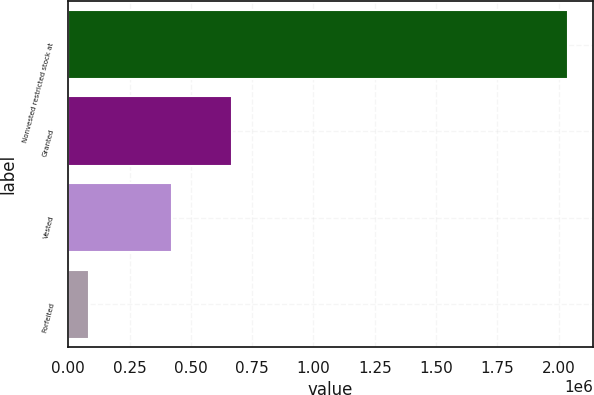<chart> <loc_0><loc_0><loc_500><loc_500><bar_chart><fcel>Nonvested restricted stock at<fcel>Granted<fcel>Vested<fcel>Forfeited<nl><fcel>2.03741e+06<fcel>666571<fcel>421261<fcel>82987<nl></chart> 